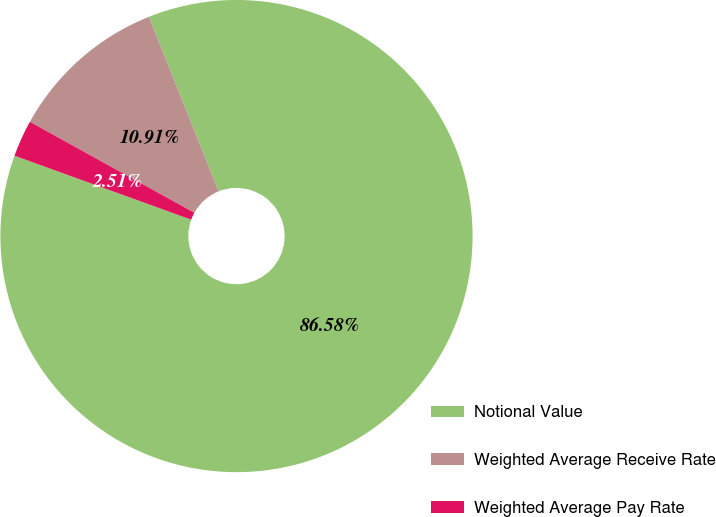Convert chart. <chart><loc_0><loc_0><loc_500><loc_500><pie_chart><fcel>Notional Value<fcel>Weighted Average Receive Rate<fcel>Weighted Average Pay Rate<nl><fcel>86.58%<fcel>10.91%<fcel>2.51%<nl></chart> 